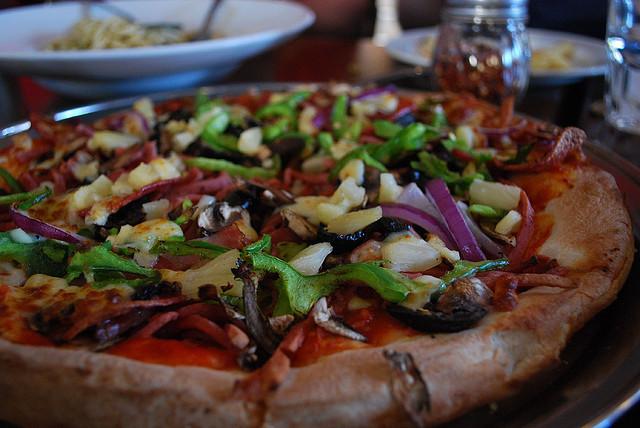What is in the shaker,  closest to the glasses?
Write a very short answer. Pepper. What color is the plate?
Short answer required. White. What green vegetable is in the dish?
Be succinct. Pepper. Is this a Philly cheesesteak?
Answer briefly. No. What is the white thing on the pizza?
Be succinct. Onion. What is the food on?
Write a very short answer. Tray. Is there a side dish?
Be succinct. Yes. Would a vegetarian eat this?
Concise answer only. Yes. Has the pizza just come out of the oven?
Write a very short answer. Yes. Is that spinach?
Quick response, please. No. Is the meal almost finished?
Concise answer only. No. What color is the baking dish?
Give a very brief answer. Silver. Are there peppers on this pizza?
Write a very short answer. Yes. What color is the pizza?
Keep it brief. Green, red, purple. What type of food is this?
Be succinct. Pizza. What single fruit item is on the pizza?
Keep it brief. Pineapple. 